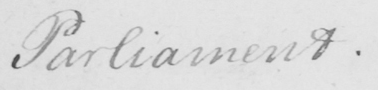Transcribe the text shown in this historical manuscript line. Parliament . 